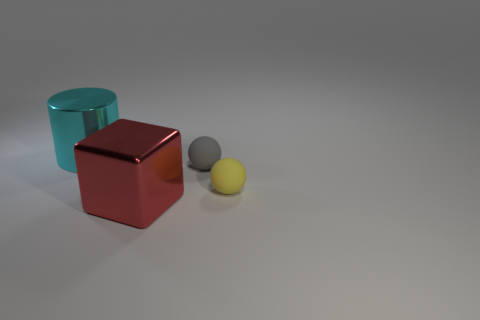Add 2 tiny objects. How many objects exist? 6 Subtract all cylinders. How many objects are left? 3 Subtract all big gray cylinders. Subtract all tiny gray spheres. How many objects are left? 3 Add 2 metallic cylinders. How many metallic cylinders are left? 3 Add 4 small yellow spheres. How many small yellow spheres exist? 5 Subtract 0 yellow blocks. How many objects are left? 4 